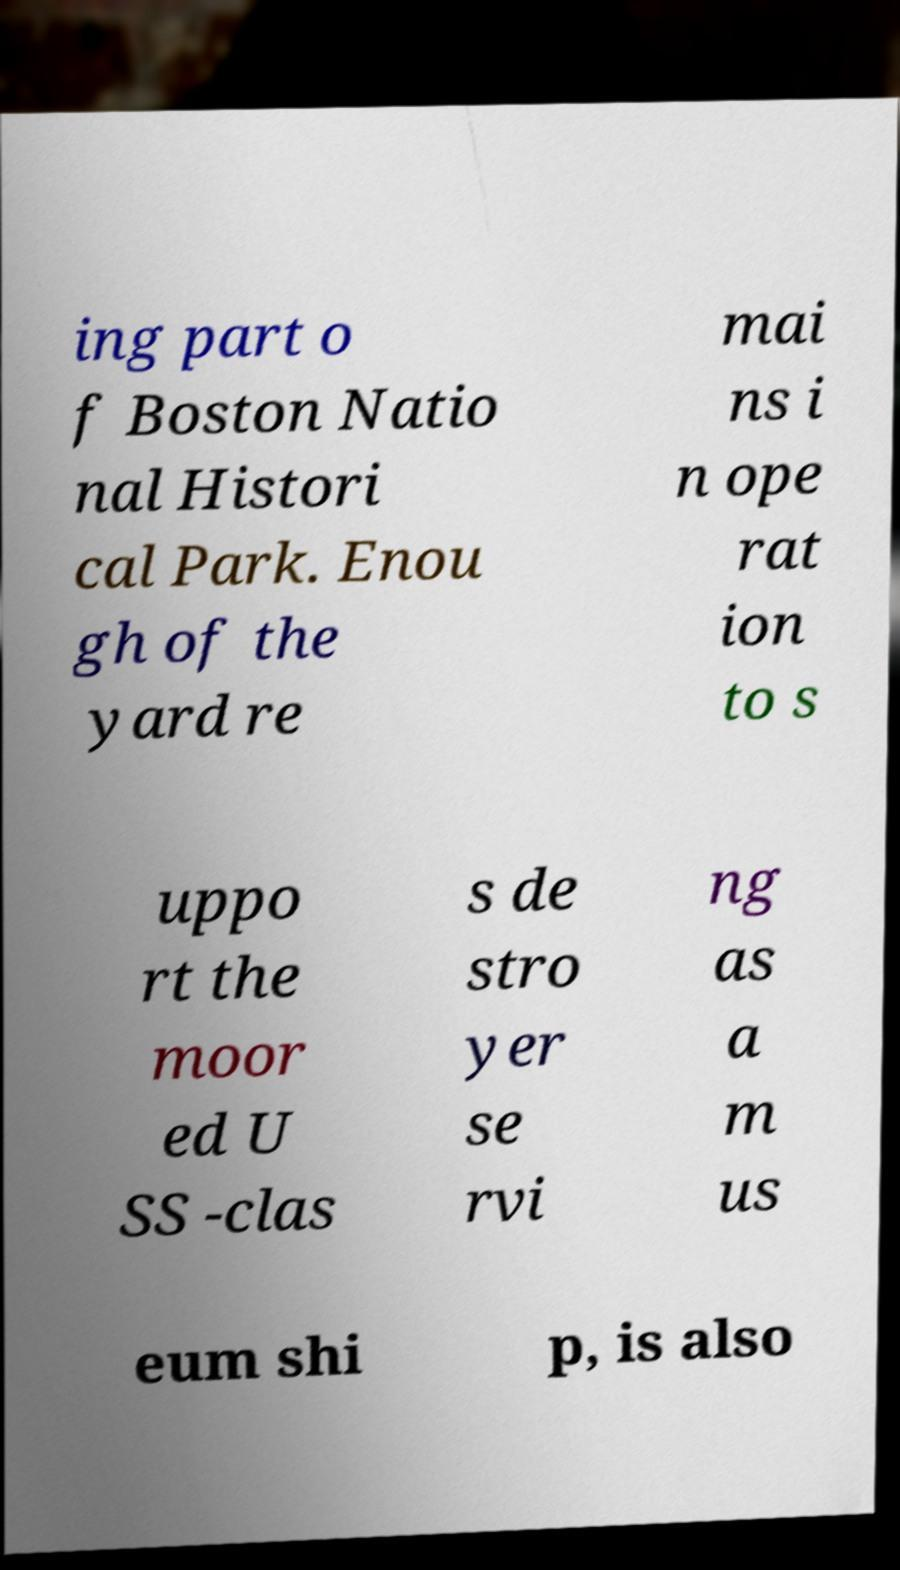Could you assist in decoding the text presented in this image and type it out clearly? ing part o f Boston Natio nal Histori cal Park. Enou gh of the yard re mai ns i n ope rat ion to s uppo rt the moor ed U SS -clas s de stro yer se rvi ng as a m us eum shi p, is also 